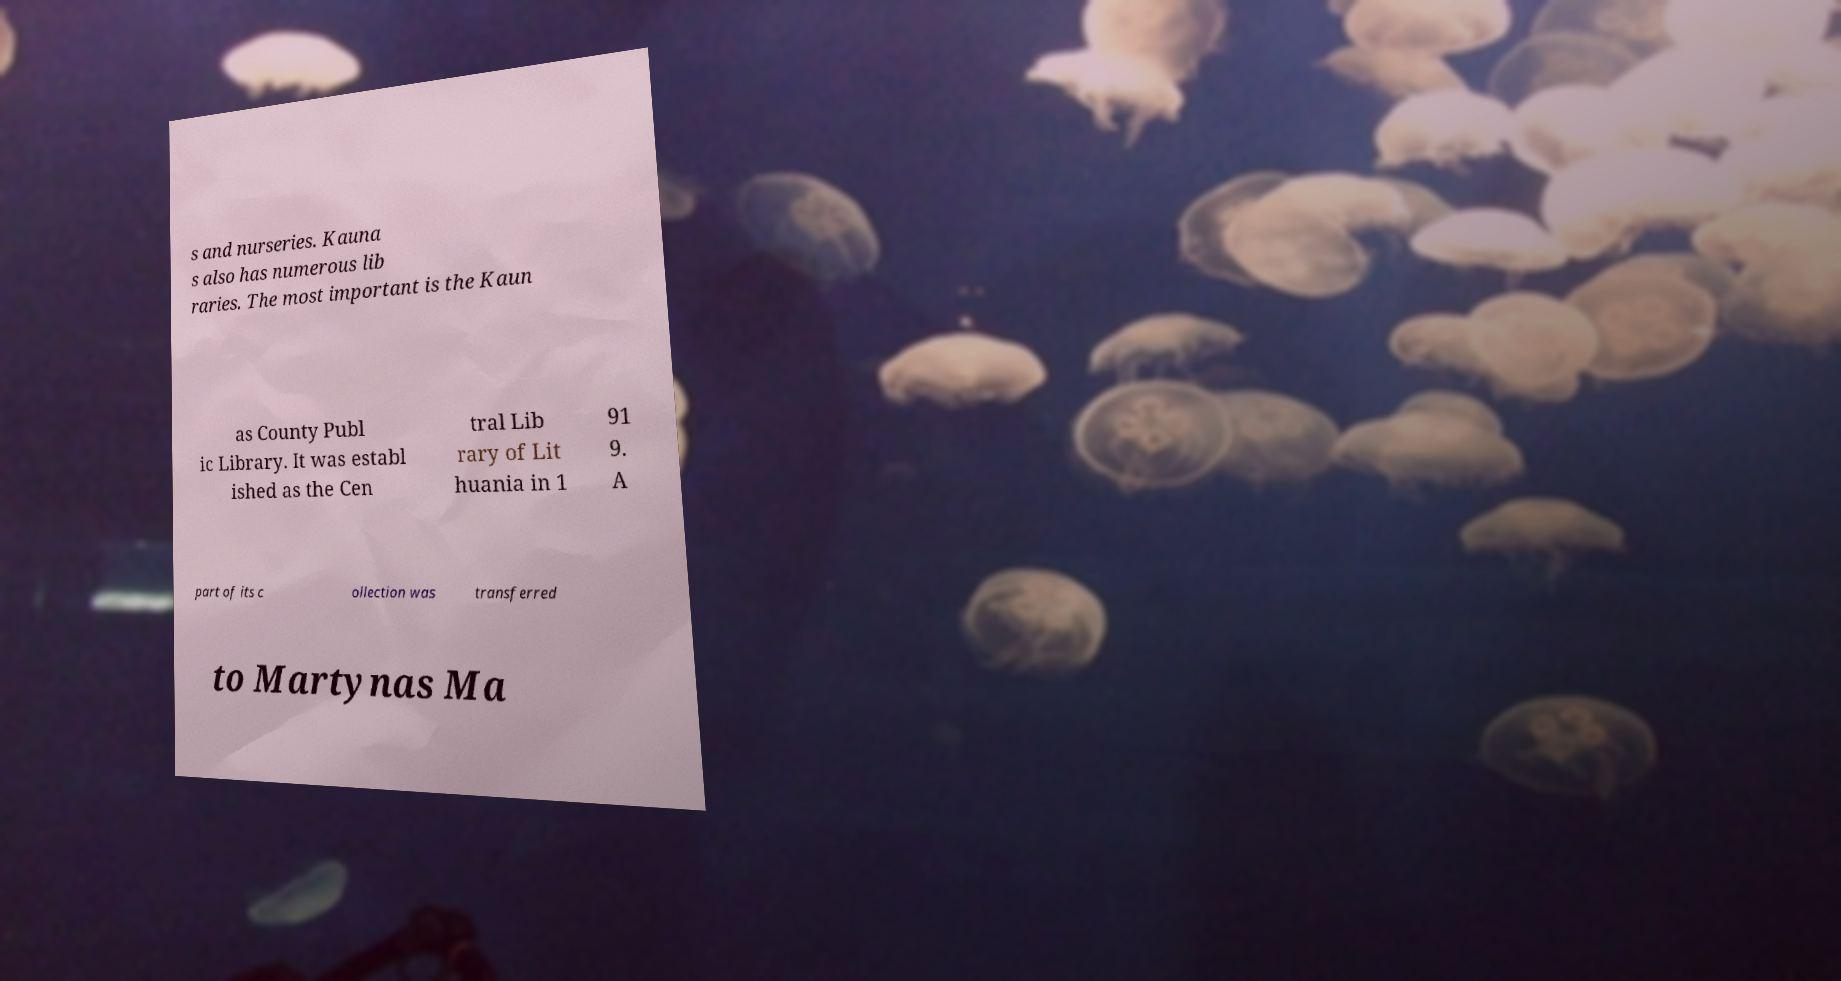Could you assist in decoding the text presented in this image and type it out clearly? s and nurseries. Kauna s also has numerous lib raries. The most important is the Kaun as County Publ ic Library. It was establ ished as the Cen tral Lib rary of Lit huania in 1 91 9. A part of its c ollection was transferred to Martynas Ma 